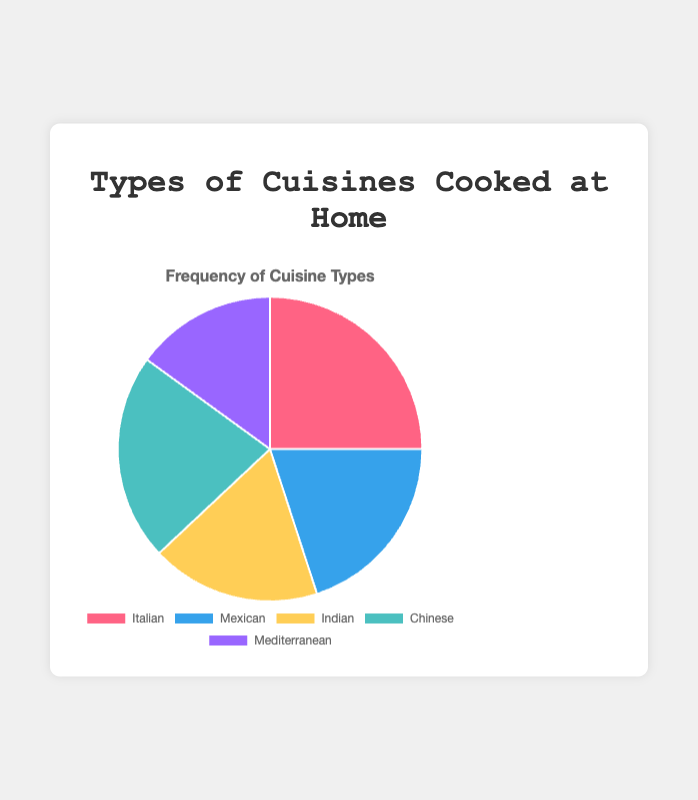What is the most frequently cooked cuisine at home? According to the pie chart, the largest segment represents Italian cuisine, indicating it is the most frequently cooked.
Answer: Italian Which cuisine has the smallest frequency? The pie chart shows the smallest segment corresponds to Mediterranean cuisine, making it the least frequently cooked.
Answer: Mediterranean How many more times is Italian cuisine cooked compared to Mediterranean cuisine? From the pie chart data, Italian cuisine is cooked 25 times and Mediterranean cuisine 15 times. The difference is 25 - 15 = 10.
Answer: 10 What is the combined frequency of Chinese and Mexican cuisines? The pie chart indicates Chinese cuisine is cooked 22 times and Mexican cuisine 20 times. The combined frequency is 22 + 20 = 42.
Answer: 42 Which cuisine is cooked more frequently: Chinese or Indian? The pie chart shows that Chinese cuisine is cooked 22 times, while Indian cuisine is cooked 18 times. 22 is greater than 18.
Answer: Chinese What percentage of the total does Mexican cuisine represent? The total frequency of all cuisines is 25 (Italian) + 20 (Mexican) + 18 (Indian) + 22 (Chinese) + 15 (Mediterranean) = 100. The percentage for Mexican is (20/100) x 100 = 20%.
Answer: 20% What is the average frequency of all cuisines cooked at home? The total frequency of all cuisines is 100. Since there are five cuisines, the average is 100 / 5 = 20.
Answer: 20 Is the frequency of Indian cuisine greater than the average frequency of all cuisines cooked at home? The average frequency of all cuisines is 20. Indian cuisine is cooked 18 times, which is less than the average frequency of 20.
Answer: No If we combine the frequencies of Indian and Mediterranean cuisines, would their total be greater than that of Italian cuisine? Indian cuisine is cooked 18 times and Mediterranean 15 times. Their combined frequency is 18 + 15 = 33, which is greater than Italian's 25.
Answer: Yes How much more frequently is Chinese cuisine cooked compared to Indian cuisine? Chinese cuisine has a frequency of 22, while Indian has 18. The difference is 22 - 18 = 4.
Answer: 4 